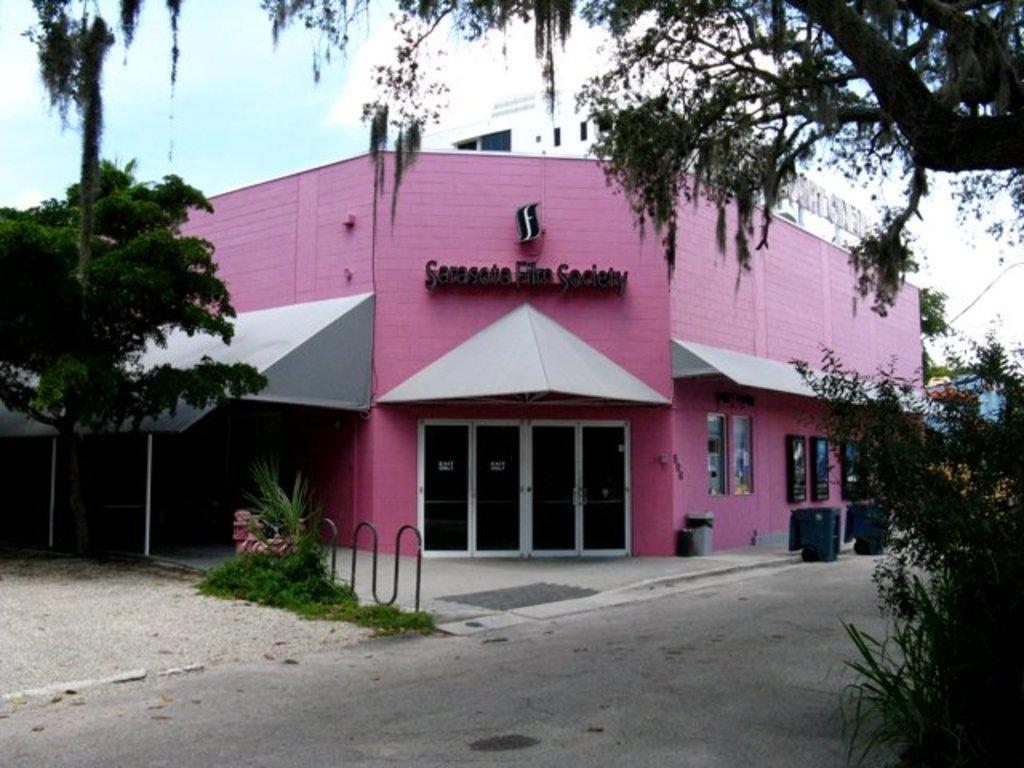Could you give a brief overview of what you see in this image? In this image there are buildings and we can see trees. There is grass and we can see doors. There are boards. In the background there is sky. 